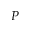Convert formula to latex. <formula><loc_0><loc_0><loc_500><loc_500>P</formula> 